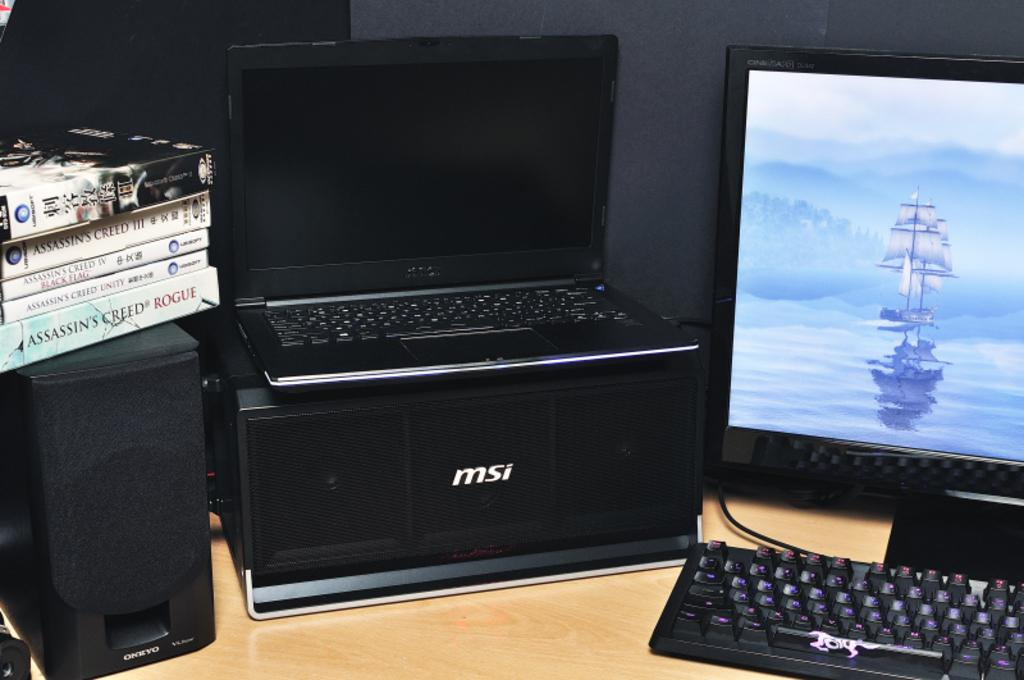Provide a one-sentence caption for the provided image. Computer setup with MSI products and a stack of assassin creed games. 